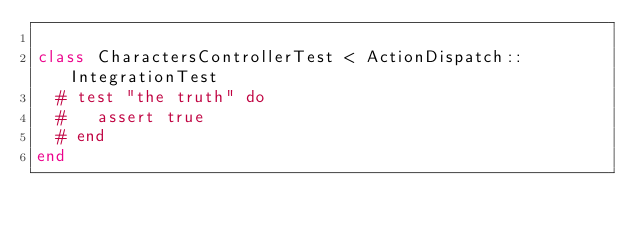<code> <loc_0><loc_0><loc_500><loc_500><_Ruby_>
class CharactersControllerTest < ActionDispatch::IntegrationTest
  # test "the truth" do
  #   assert true
  # end
end
</code> 